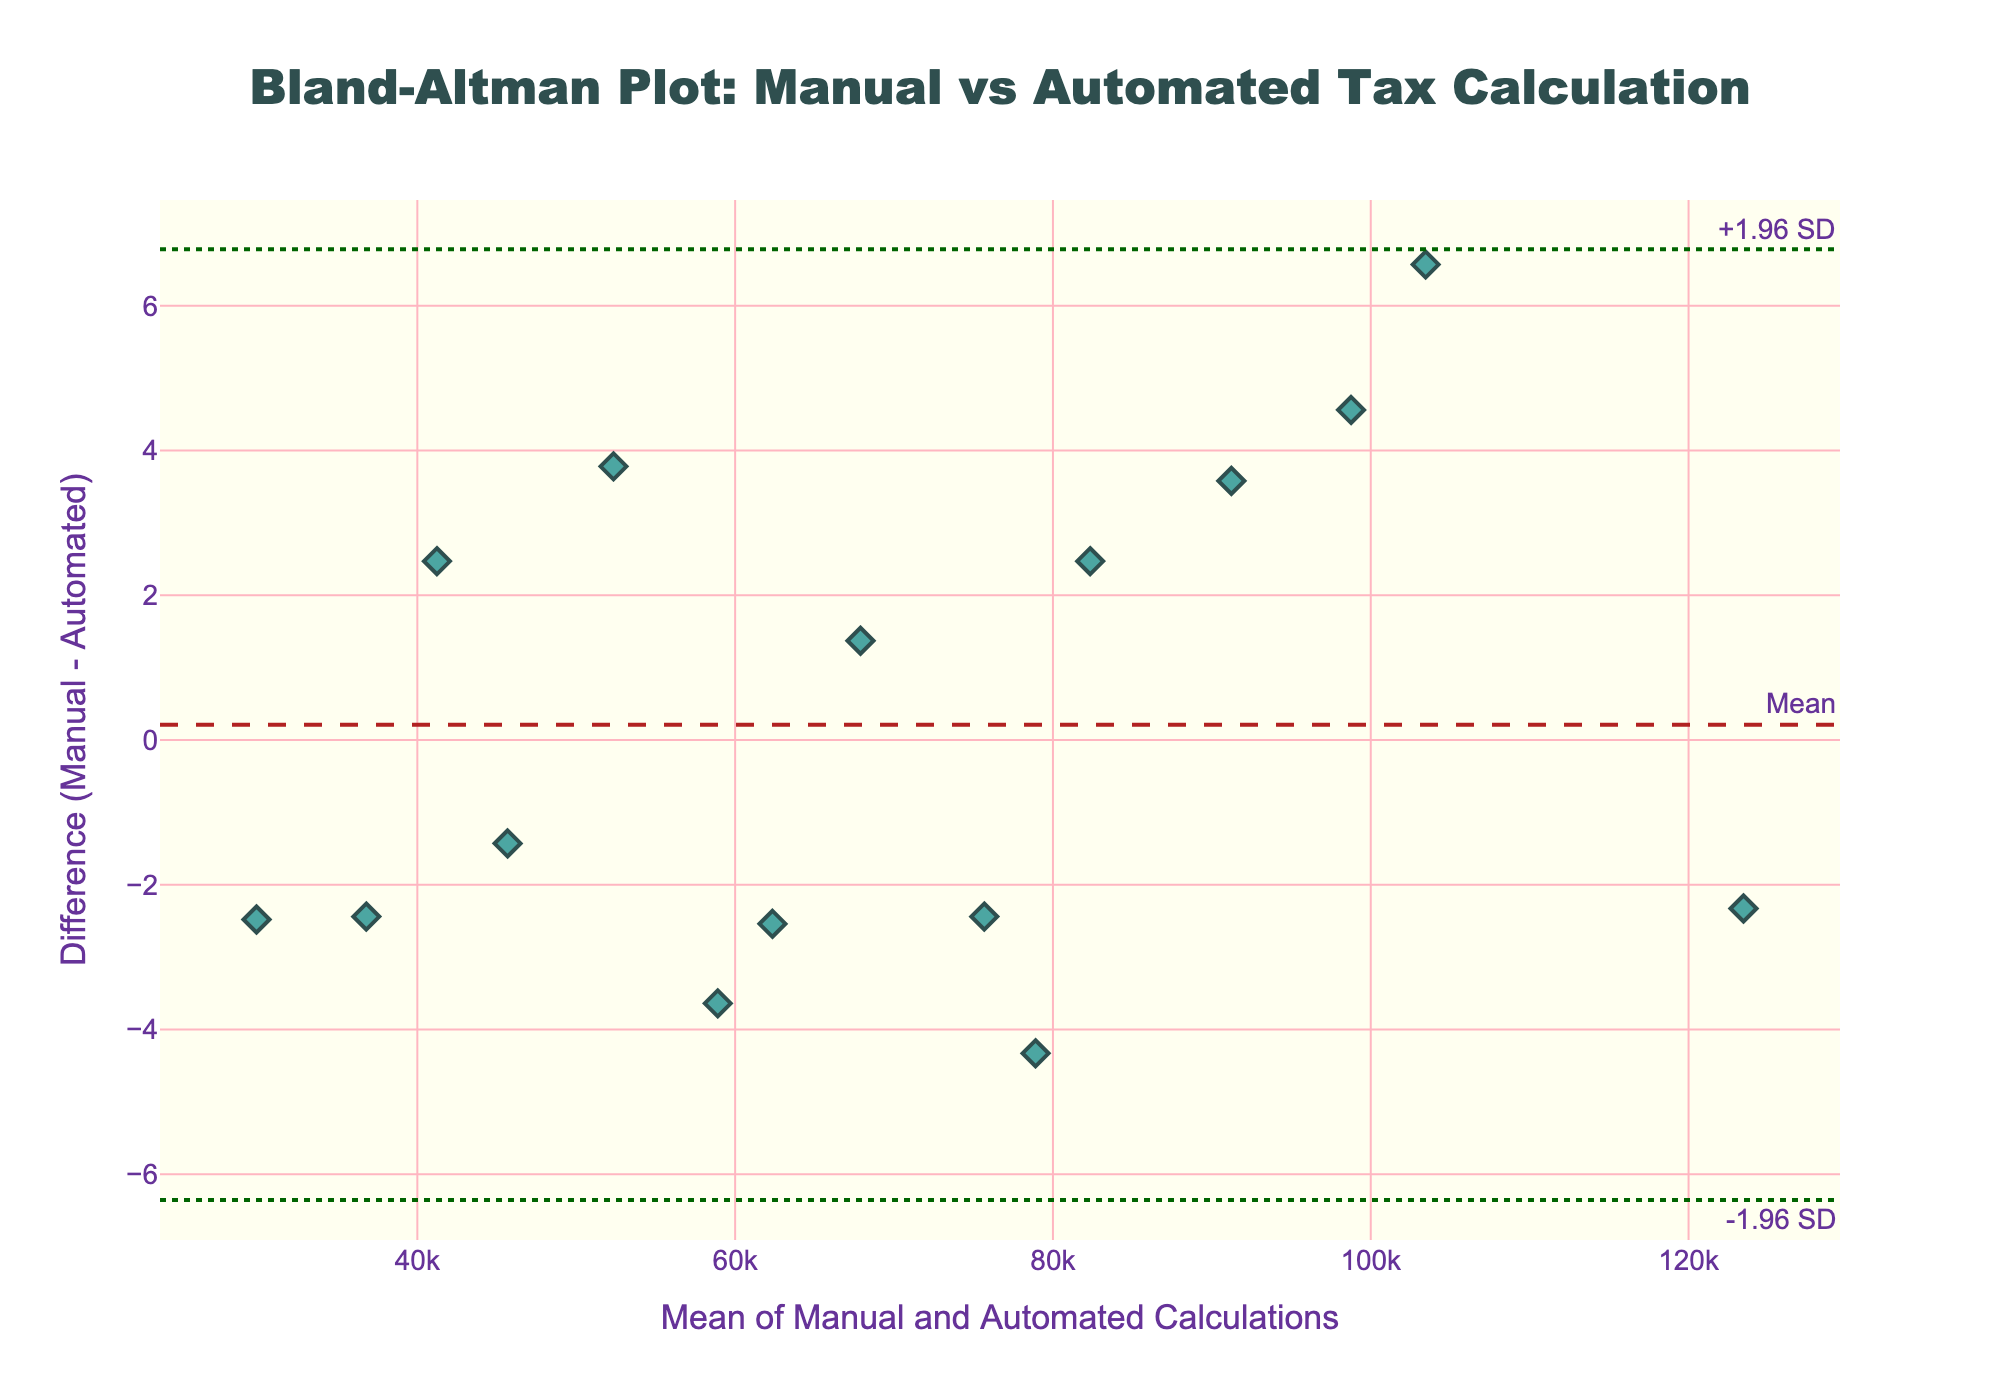What is the title of the figure? The title is displayed at the top of the figure and reads "Bland-Altman Plot: Manual vs Automated Tax Calculation".
Answer: Bland-Altman Plot: Manual vs Automated Tax Calculation What is shown on the X-axis in the plot? The label on the X-axis indicates "Mean of Manual and Automated Calculations".
Answer: Mean of Manual and Automated Calculations What is the Y-axis representing in the plot? The Y-axis label indicates "Difference (Manual - Automated)".
Answer: Difference (Manual - Automated) How many data points are depicted in the plot? Each data point represents a comparison between manual and automated calculations. There are 15 data points on the plot.
Answer: 15 What color are the data points in the plot? The data points are colored in a teal shade.
Answer: Teal Which horizontal line represents the mean difference? The mean difference is represented by a dashed horizontal line labeled "Mean" and colored in firebrick.
Answer: Firebrick dashed line What are the approximate values of the +1.96 SD and -1.96 SD lines? The +1.96 SD and -1.96 SD lines are represented by dotted dark green lines. These lines can be read from their positions on the plot.
Answer: Approximate values are +1.96 SD and -1.96 SD lines What is the approximate mean difference between manual and automated calculations? The mean difference is shown by the firebrick dashed line. The position of this line on the Y-axis gives the mean difference.
Answer: Approximately 0 How close are the differences to the mean difference? By observing the spread of data points around the firebrick dashed line (mean difference), we can see if they are widely dispersed or closely packed.
Answer: Close Which pair has the largest positive difference (Manual - Automated)? Identify the data point with the highest position on the Y-axis (positive side).
Answer: The tax calculation around the 100,000 range has the largest positive difference Which pair has the largest negative difference (Manual - Automated)? Identify the data point with the lowest position on the Y-axis (negative side).
Answer: The tax calculation around the 90,000 range has the largest negative difference 